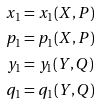Convert formula to latex. <formula><loc_0><loc_0><loc_500><loc_500>x _ { 1 } & = x _ { 1 } ( X , P ) \\ p _ { 1 } & = p _ { 1 } ( X , P ) \\ y _ { 1 } & = y _ { 1 } ( Y , Q ) \\ q _ { 1 } & = q _ { 1 } ( Y , Q )</formula> 